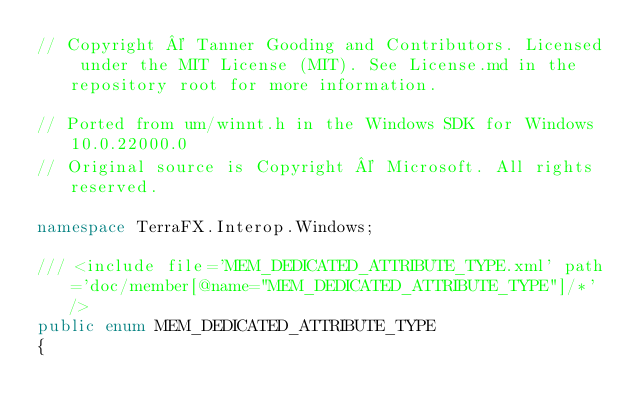<code> <loc_0><loc_0><loc_500><loc_500><_C#_>// Copyright © Tanner Gooding and Contributors. Licensed under the MIT License (MIT). See License.md in the repository root for more information.

// Ported from um/winnt.h in the Windows SDK for Windows 10.0.22000.0
// Original source is Copyright © Microsoft. All rights reserved.

namespace TerraFX.Interop.Windows;

/// <include file='MEM_DEDICATED_ATTRIBUTE_TYPE.xml' path='doc/member[@name="MEM_DEDICATED_ATTRIBUTE_TYPE"]/*' />
public enum MEM_DEDICATED_ATTRIBUTE_TYPE
{</code> 